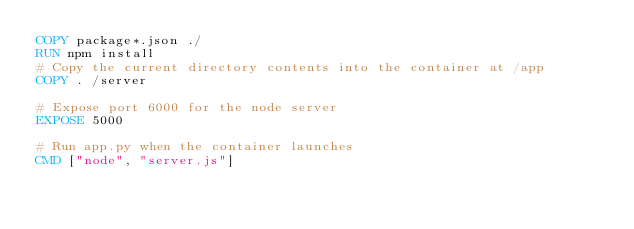Convert code to text. <code><loc_0><loc_0><loc_500><loc_500><_Dockerfile_>COPY package*.json ./
RUN npm install
# Copy the current directory contents into the container at /app
COPY . /server

# Expose port 6000 for the node server
EXPOSE 5000

# Run app.py when the container launches
CMD ["node", "server.js"]</code> 